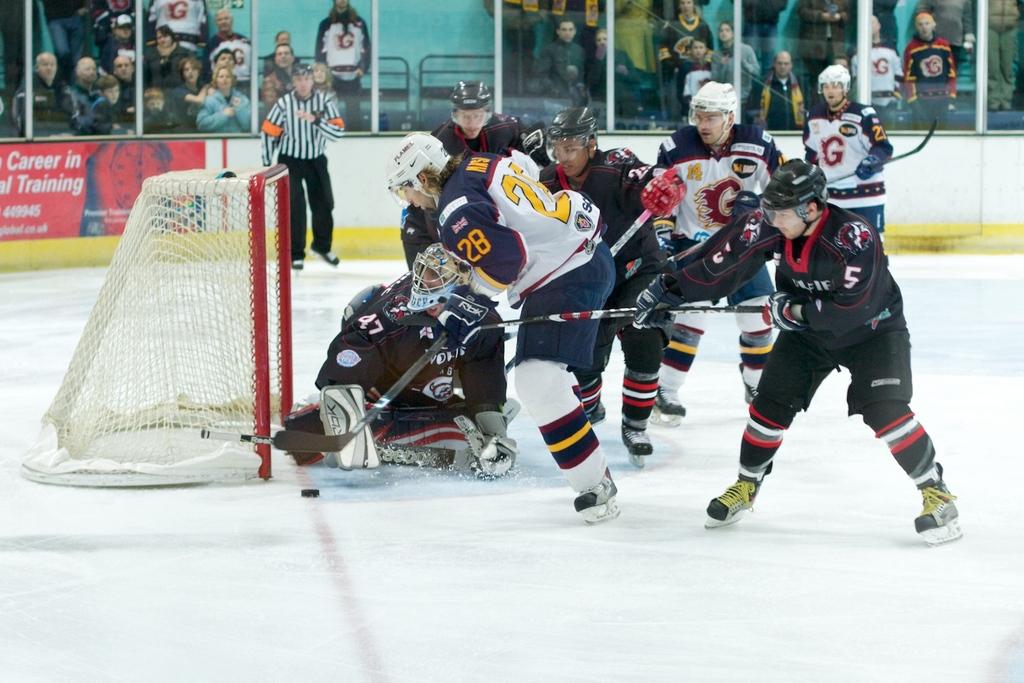What is the number of a player in blue?
Make the answer very short. 28. What number is the goalie wearing?
Make the answer very short. 47. 